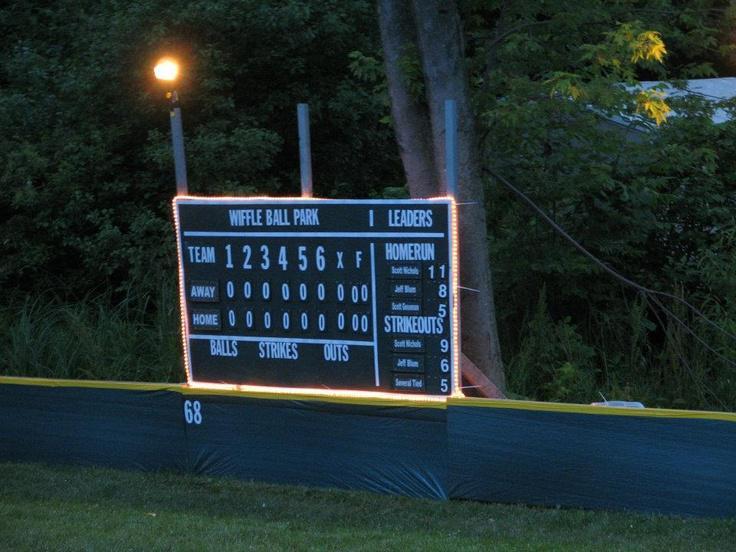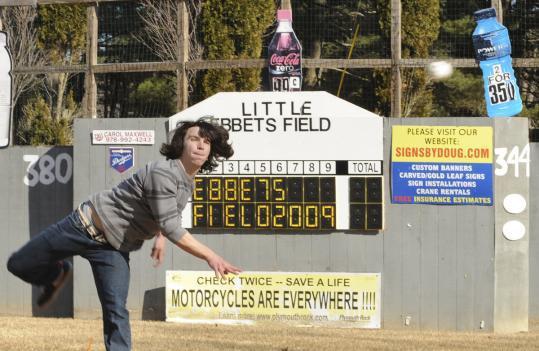The first image is the image on the left, the second image is the image on the right. For the images shown, is this caption "One of the images shows a scoreboard with no people around and the other image shows a scoreboard with a team of players on the field." true? Answer yes or no. No. The first image is the image on the left, the second image is the image on the right. Evaluate the accuracy of this statement regarding the images: "Twelve or more individual digits are illuminated in one of the images.". Is it true? Answer yes or no. Yes. 